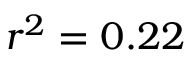Convert formula to latex. <formula><loc_0><loc_0><loc_500><loc_500>r ^ { 2 } = 0 . 2 2</formula> 